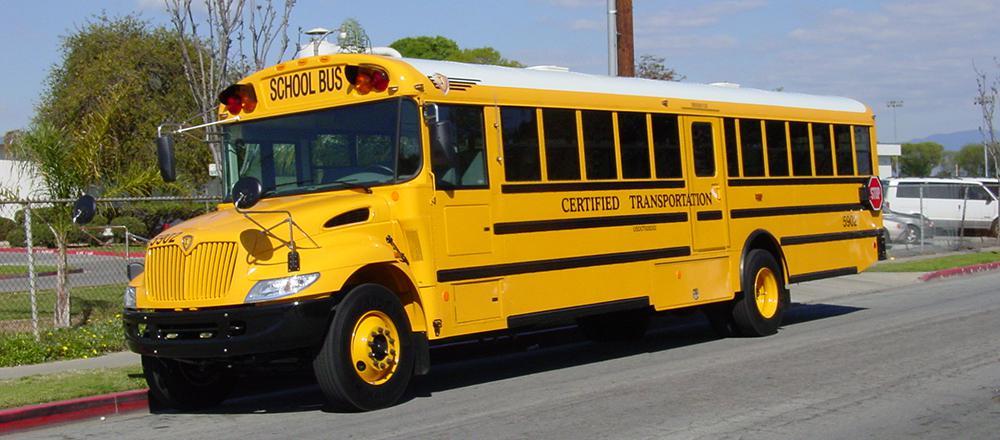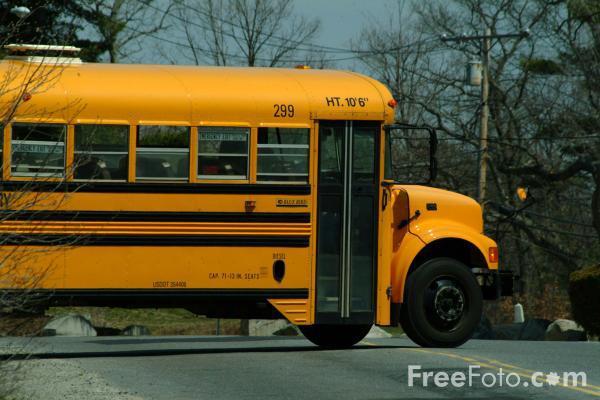The first image is the image on the left, the second image is the image on the right. Evaluate the accuracy of this statement regarding the images: "Each image shows a bus with a non-flat front that is facing toward the camera.". Is it true? Answer yes or no. No. 